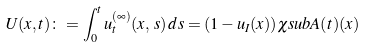Convert formula to latex. <formula><loc_0><loc_0><loc_500><loc_500>U ( x , t ) \colon = \int _ { 0 } ^ { t } u ^ { ( \infty ) } _ { t } ( x , \, s ) \, d s = ( 1 - u _ { I } ( x ) ) \chi s u b { A ( t ) } ( x )</formula> 